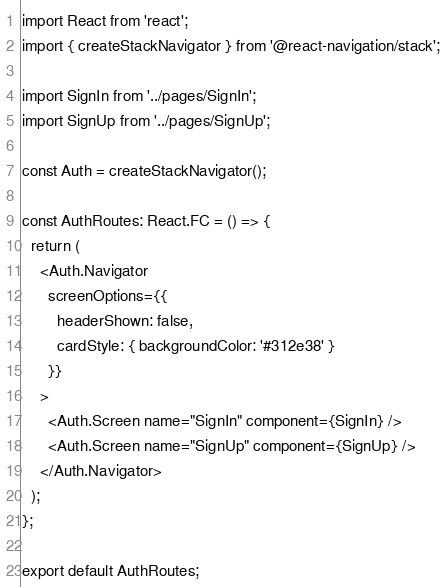Convert code to text. <code><loc_0><loc_0><loc_500><loc_500><_TypeScript_>import React from 'react';
import { createStackNavigator } from '@react-navigation/stack';

import SignIn from '../pages/SignIn';
import SignUp from '../pages/SignUp';

const Auth = createStackNavigator();

const AuthRoutes: React.FC = () => {
  return (
    <Auth.Navigator
      screenOptions={{
        headerShown: false,
        cardStyle: { backgroundColor: '#312e38' }
      }}
    >
      <Auth.Screen name="SignIn" component={SignIn} />
      <Auth.Screen name="SignUp" component={SignUp} />
    </Auth.Navigator>
  );
};

export default AuthRoutes;
</code> 